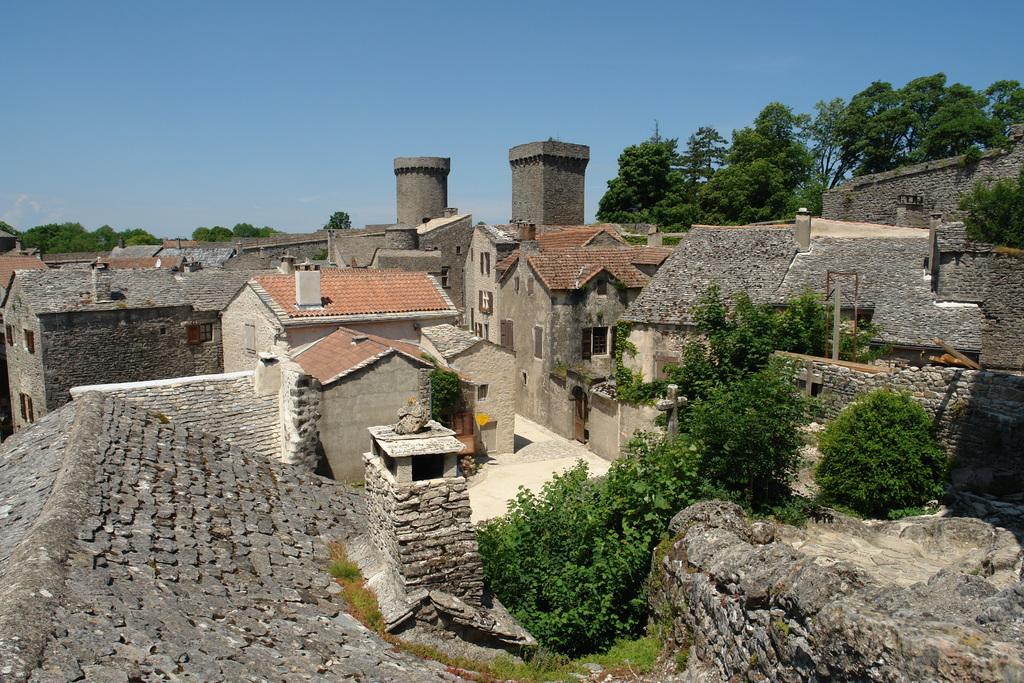Could you give a brief overview of what you see in this image? In this image there are houses and trees. 